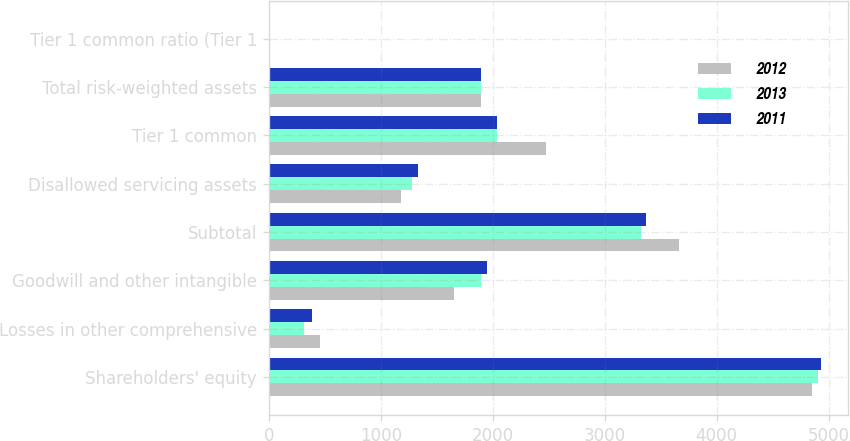Convert chart. <chart><loc_0><loc_0><loc_500><loc_500><stacked_bar_chart><ecel><fcel>Shareholders' equity<fcel>Losses in other comprehensive<fcel>Goodwill and other intangible<fcel>Subtotal<fcel>Disallowed servicing assets<fcel>Tier 1 common<fcel>Total risk-weighted assets<fcel>Tier 1 common ratio (Tier 1<nl><fcel>2012<fcel>4855.9<fcel>459<fcel>1654.2<fcel>3660.7<fcel>1185.4<fcel>2475.3<fcel>1899.4<fcel>13.8<nl><fcel>2013<fcel>4904.5<fcel>315.4<fcel>1899.4<fcel>3320.5<fcel>1278.9<fcel>2041.6<fcel>1899.4<fcel>10.3<nl><fcel>2011<fcel>4928<fcel>389.6<fcel>1947.5<fcel>3370.1<fcel>1331<fcel>2039.1<fcel>1899.4<fcel>9.4<nl></chart> 